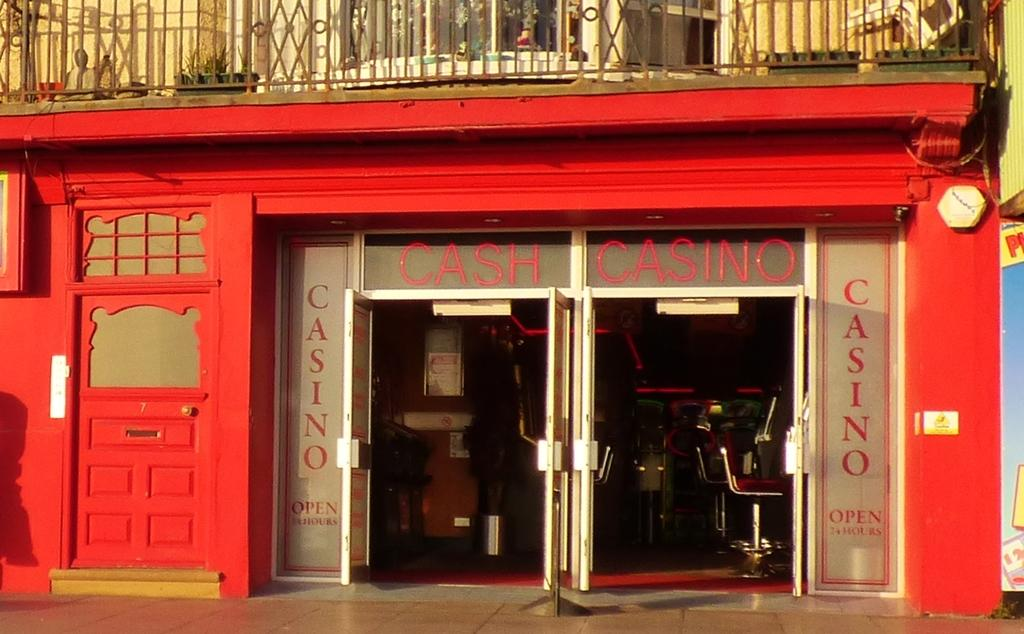What type of establishment is depicted in the image? There is a store in the image. What are the main entry points for the store? There are doors in the image. What type of security feature is present in the image? There is a grille in the image. What type of furniture is present in the image? There are chairs in the image. What type of signage is present in the image? There is a hoarding in the image. What type of greenery is present in the image? There is a plant behind the grille in the image. What type of railway is visible in the image? There is no railway present in the image. What type of stitch is used to hold the town together in the image? There is no town or stitching present in the image. 